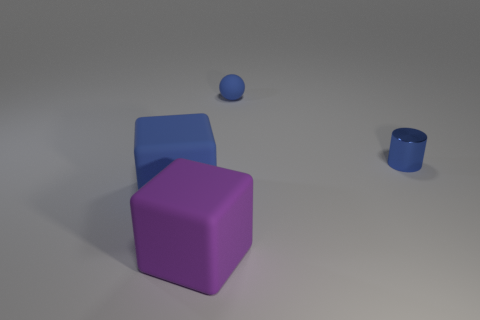Is there any indication of the texture of the objects? The large purple block and the blue sphere have a matte finish, indicating a non-reflective, possibly textured surface. The smaller blue block appears to have a slight shine to it, suggesting a smoother, perhaps slightly reflective texture. Could you speculate on the purpose or function of these objects, if any? Without additional context, it is difficult to ascertain the exact purpose of these objects. They could be simple geometric shapes used for educational purposes, elements of a minimalist art installation, or part of a 3D modeling project. 